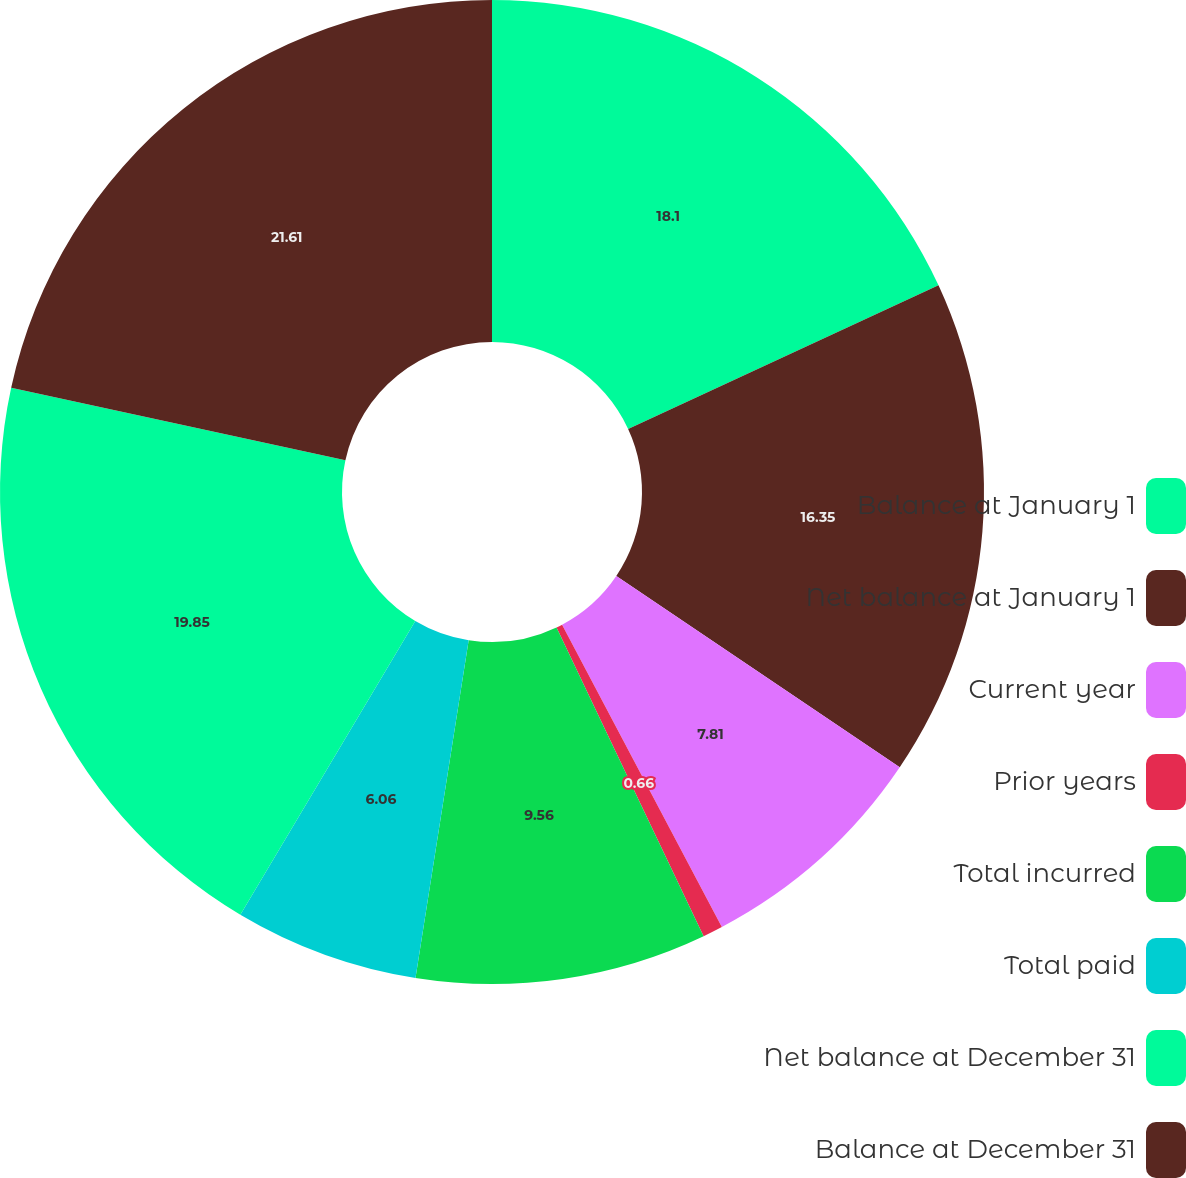<chart> <loc_0><loc_0><loc_500><loc_500><pie_chart><fcel>Balance at January 1<fcel>Net balance at January 1<fcel>Current year<fcel>Prior years<fcel>Total incurred<fcel>Total paid<fcel>Net balance at December 31<fcel>Balance at December 31<nl><fcel>18.1%<fcel>16.35%<fcel>7.81%<fcel>0.66%<fcel>9.56%<fcel>6.06%<fcel>19.85%<fcel>21.6%<nl></chart> 